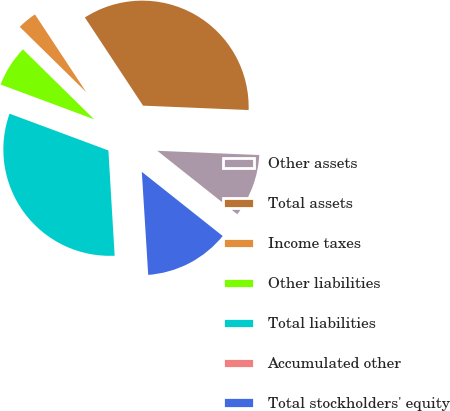<chart> <loc_0><loc_0><loc_500><loc_500><pie_chart><fcel>Other assets<fcel>Total assets<fcel>Income taxes<fcel>Other liabilities<fcel>Total liabilities<fcel>Accumulated other<fcel>Total stockholders' equity<nl><fcel>10.01%<fcel>34.94%<fcel>3.36%<fcel>6.69%<fcel>31.61%<fcel>0.04%<fcel>13.34%<nl></chart> 